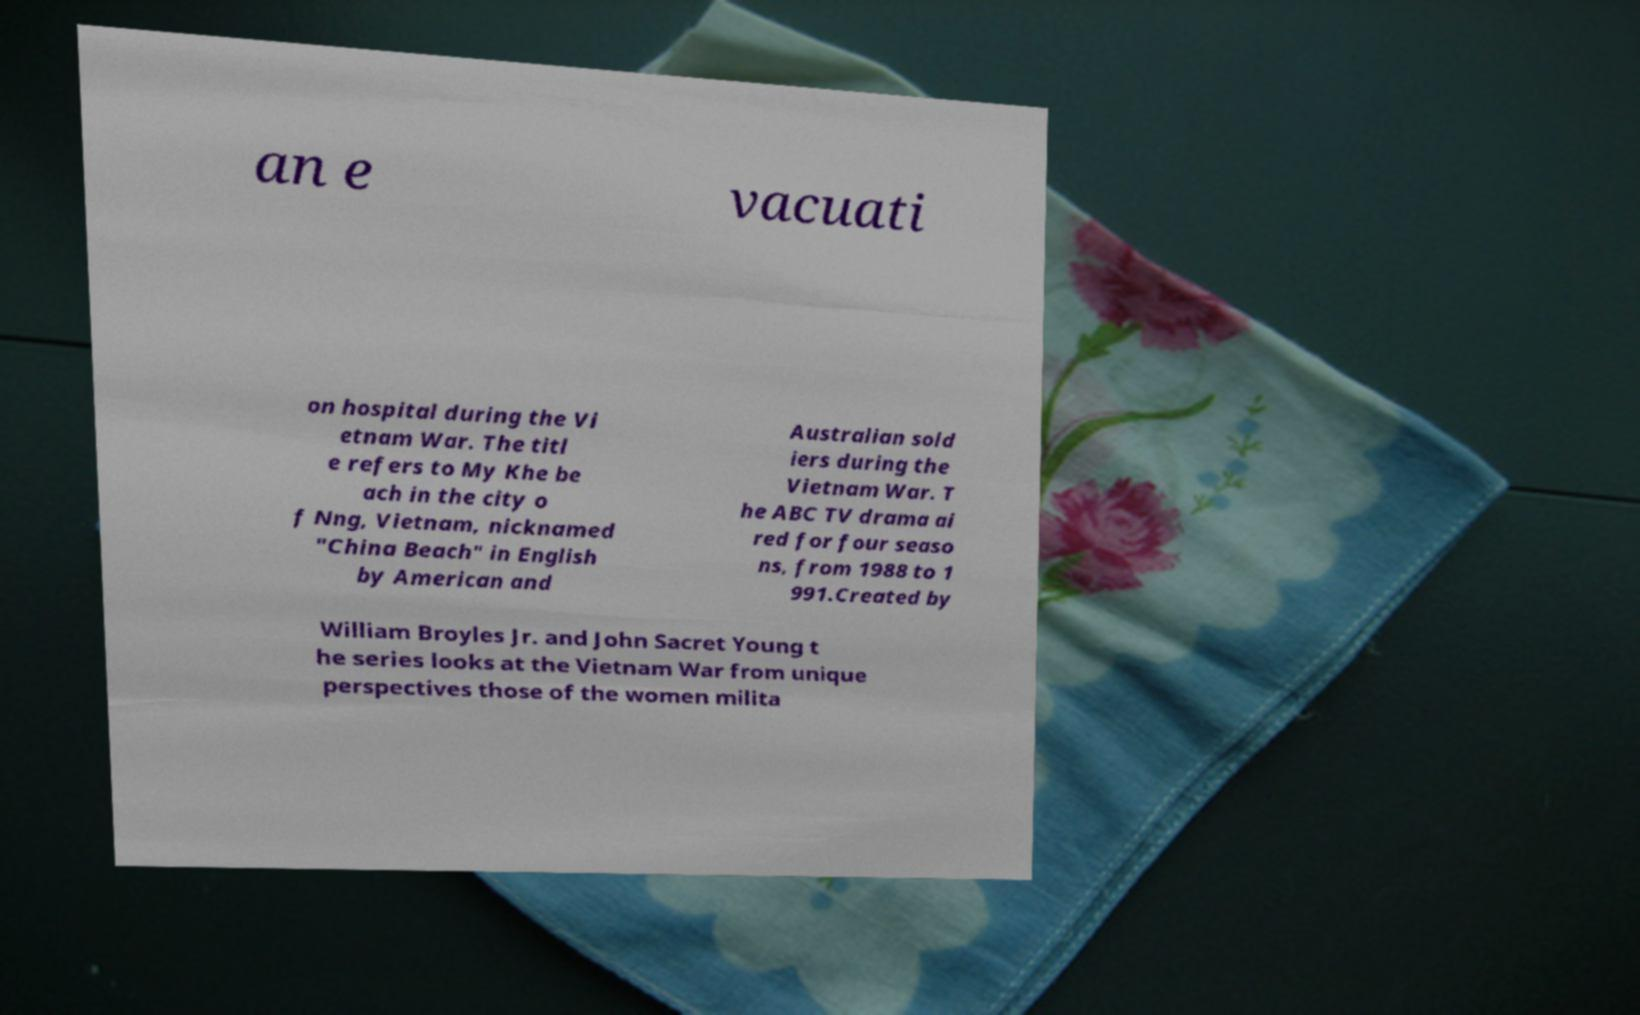For documentation purposes, I need the text within this image transcribed. Could you provide that? an e vacuati on hospital during the Vi etnam War. The titl e refers to My Khe be ach in the city o f Nng, Vietnam, nicknamed "China Beach" in English by American and Australian sold iers during the Vietnam War. T he ABC TV drama ai red for four seaso ns, from 1988 to 1 991.Created by William Broyles Jr. and John Sacret Young t he series looks at the Vietnam War from unique perspectives those of the women milita 